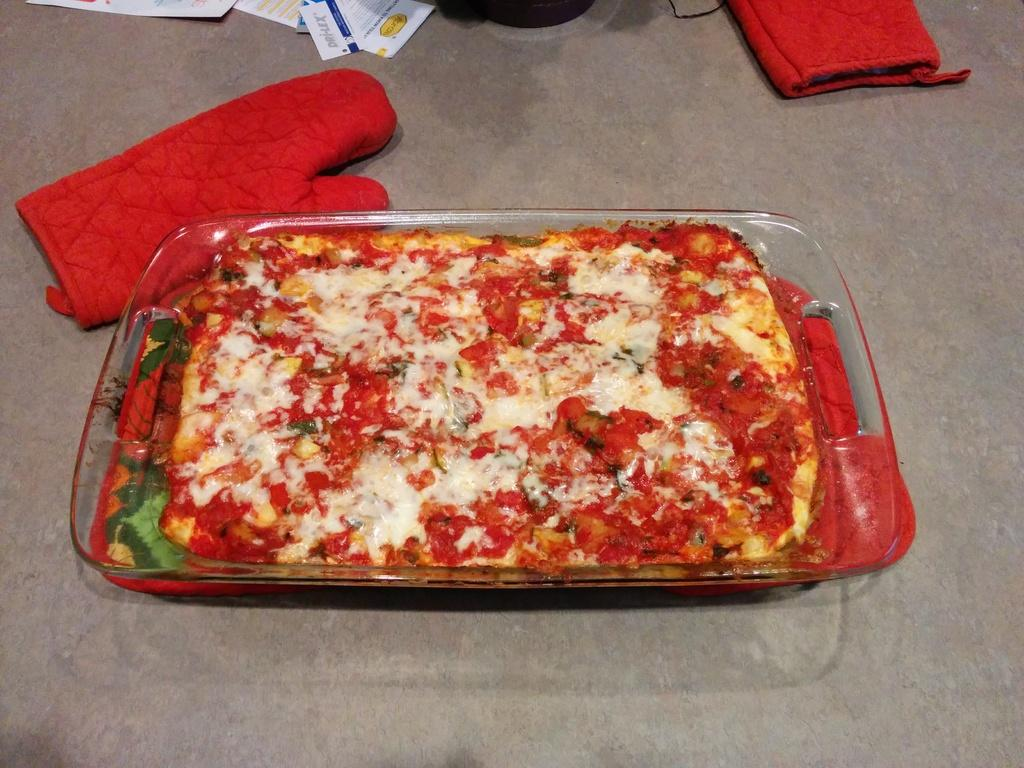What is on the tray that is visible in the image? There is a tray with food in the image. Where is the tray located in the image? The tray is on the floor in the image. What other items can be seen in the image besides the tray? There are gloves and papers visible in the image. Can you describe the unspecified object on the tray? Unfortunately, the facts provided do not specify the nature of the unspecified object on the tray. What type of game is being played by the family in the image? There is no game or family present in the image; it features a tray with food on the floor, gloves, and papers. 